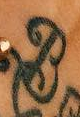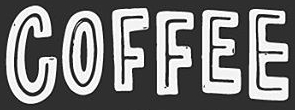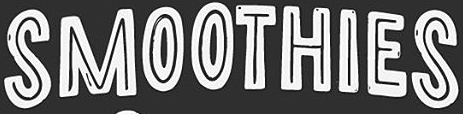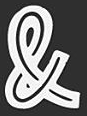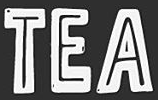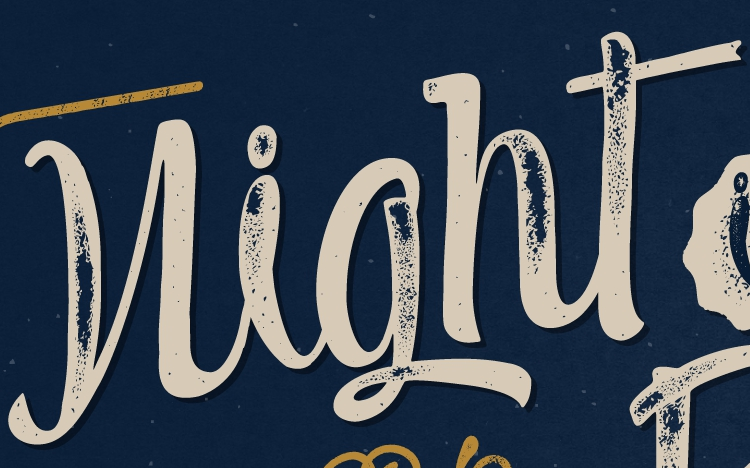What text is displayed in these images sequentially, separated by a semicolon? B; COFFEE; SMOOTHIES; &; TEA; night 